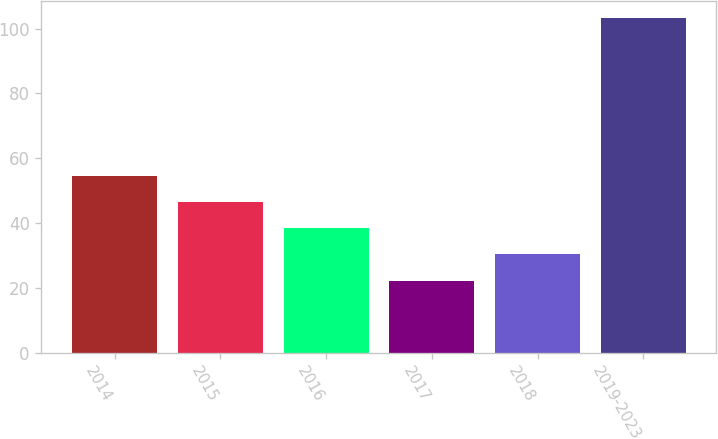Convert chart. <chart><loc_0><loc_0><loc_500><loc_500><bar_chart><fcel>2014<fcel>2015<fcel>2016<fcel>2017<fcel>2018<fcel>2019-2023<nl><fcel>54.6<fcel>46.5<fcel>38.4<fcel>22.2<fcel>30.3<fcel>103.2<nl></chart> 